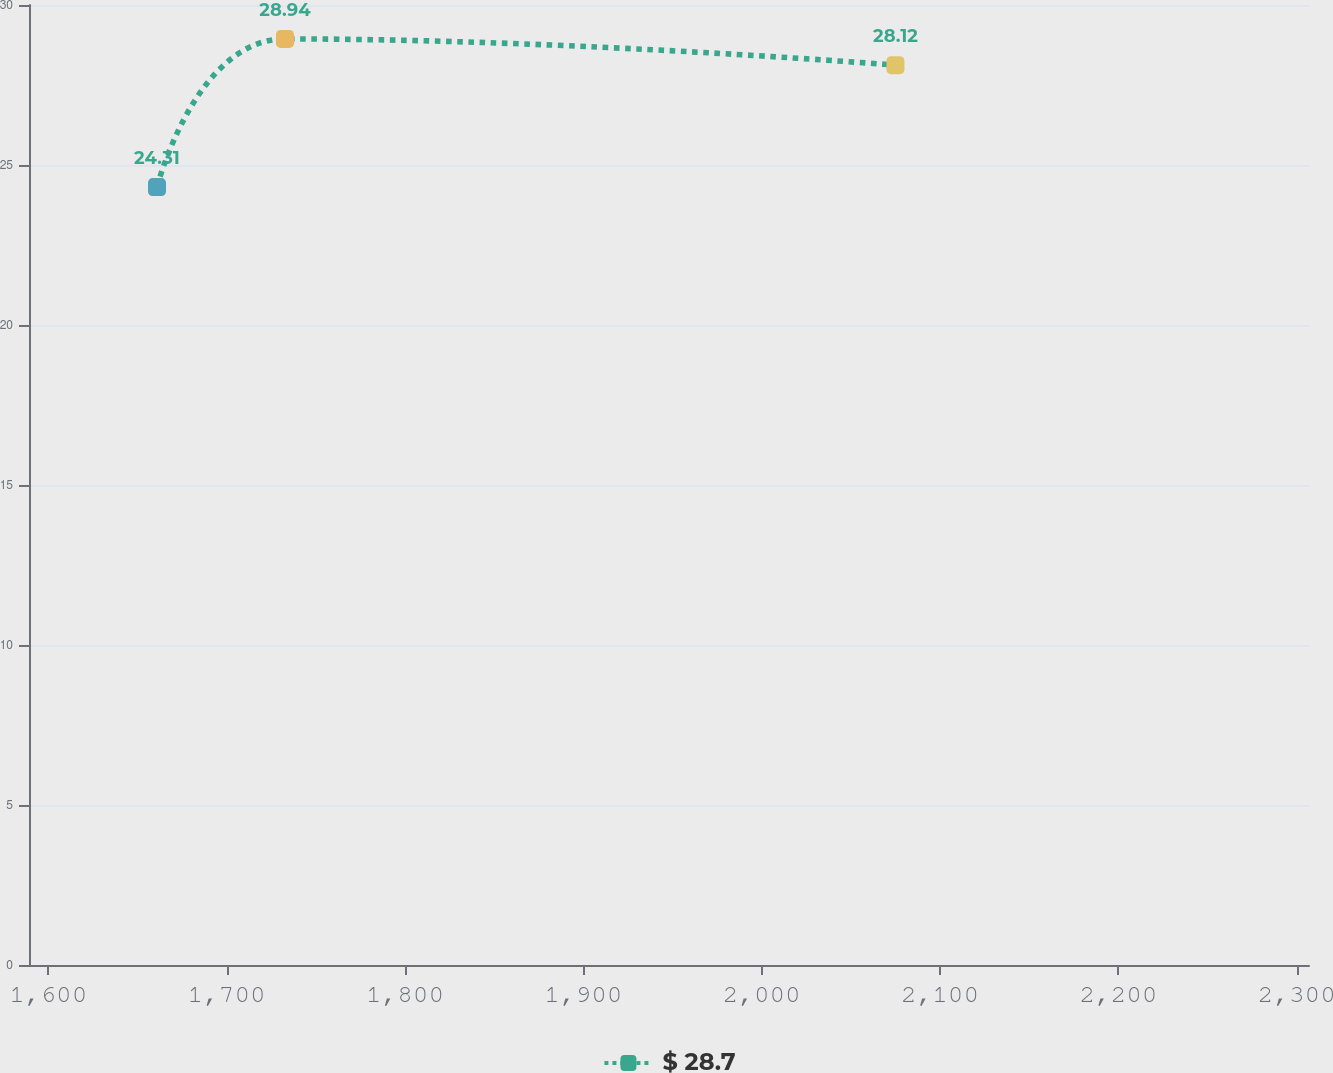Convert chart. <chart><loc_0><loc_0><loc_500><loc_500><line_chart><ecel><fcel>$ 28.7<nl><fcel>1660.97<fcel>24.31<nl><fcel>1732.73<fcel>28.94<nl><fcel>2074.97<fcel>28.12<nl><fcel>2378.61<fcel>32.5<nl></chart> 